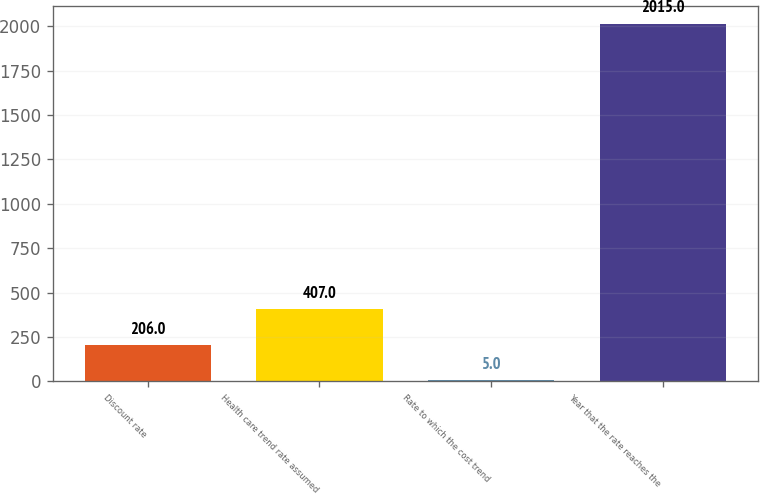Convert chart. <chart><loc_0><loc_0><loc_500><loc_500><bar_chart><fcel>Discount rate<fcel>Health care trend rate assumed<fcel>Rate to which the cost trend<fcel>Year that the rate reaches the<nl><fcel>206<fcel>407<fcel>5<fcel>2015<nl></chart> 